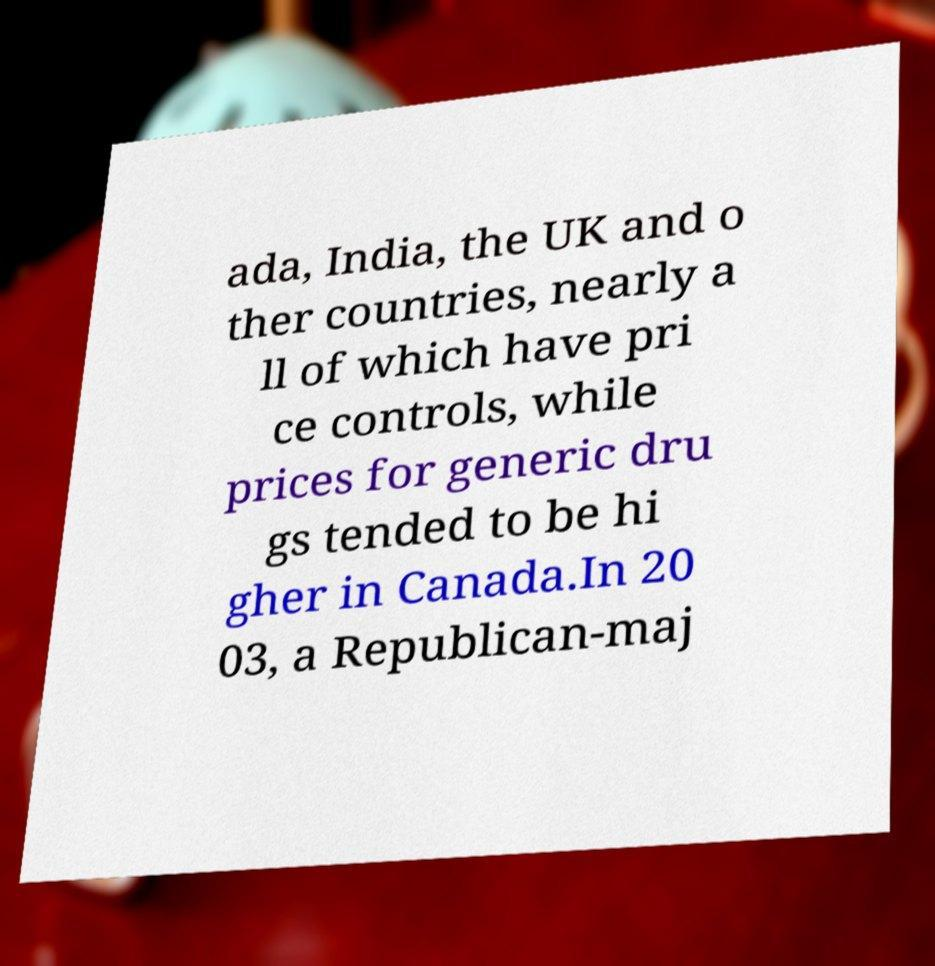Could you assist in decoding the text presented in this image and type it out clearly? ada, India, the UK and o ther countries, nearly a ll of which have pri ce controls, while prices for generic dru gs tended to be hi gher in Canada.In 20 03, a Republican-maj 